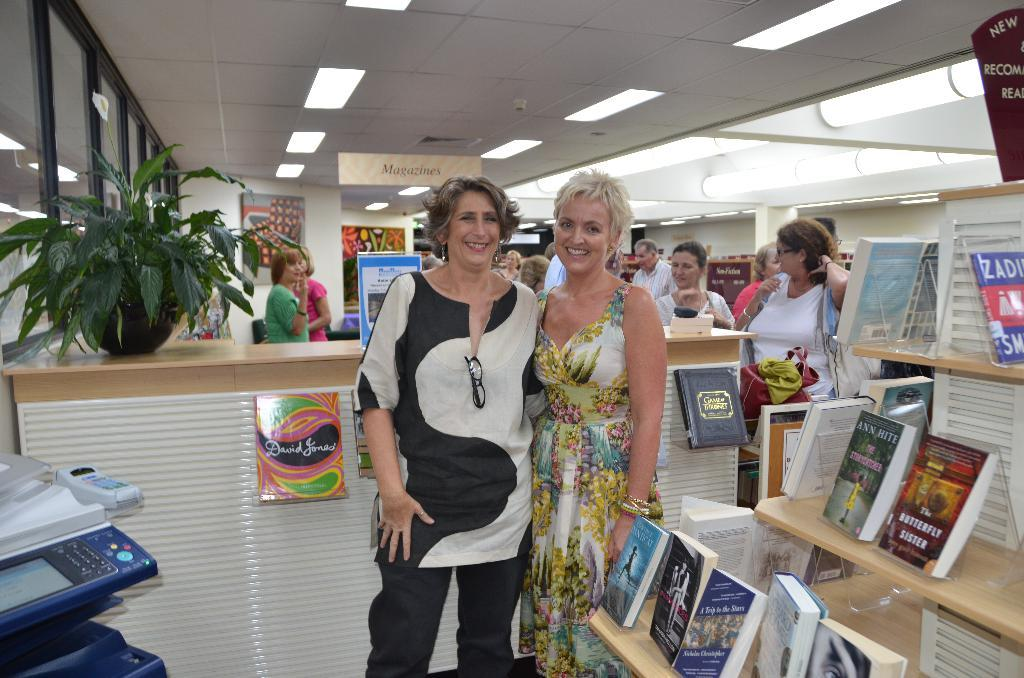How many people are in the image? There are two persons standing together in the image. What is the location of the persons in the image? The persons are standing in front of a table. What can be seen beside the persons? There is a shelf with books beside the persons. How many books are on the shelf? The shelf contains many books. What is the source of light in the room? There are lights in the roof of the room. Where is the sink located in the image? There is no sink present in the image. What type of honey is being used by the persons in the image? There is no honey present in the image. 